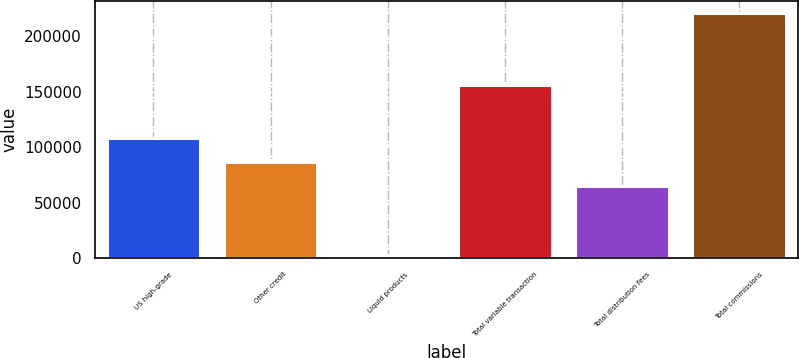Convert chart to OTSL. <chart><loc_0><loc_0><loc_500><loc_500><bar_chart><fcel>US high-grade<fcel>Other credit<fcel>Liquid products<fcel>Total variable transaction<fcel>Total distribution fees<fcel>Total commissions<nl><fcel>108564<fcel>86733.8<fcel>2840<fcel>156234<fcel>64904<fcel>221138<nl></chart> 